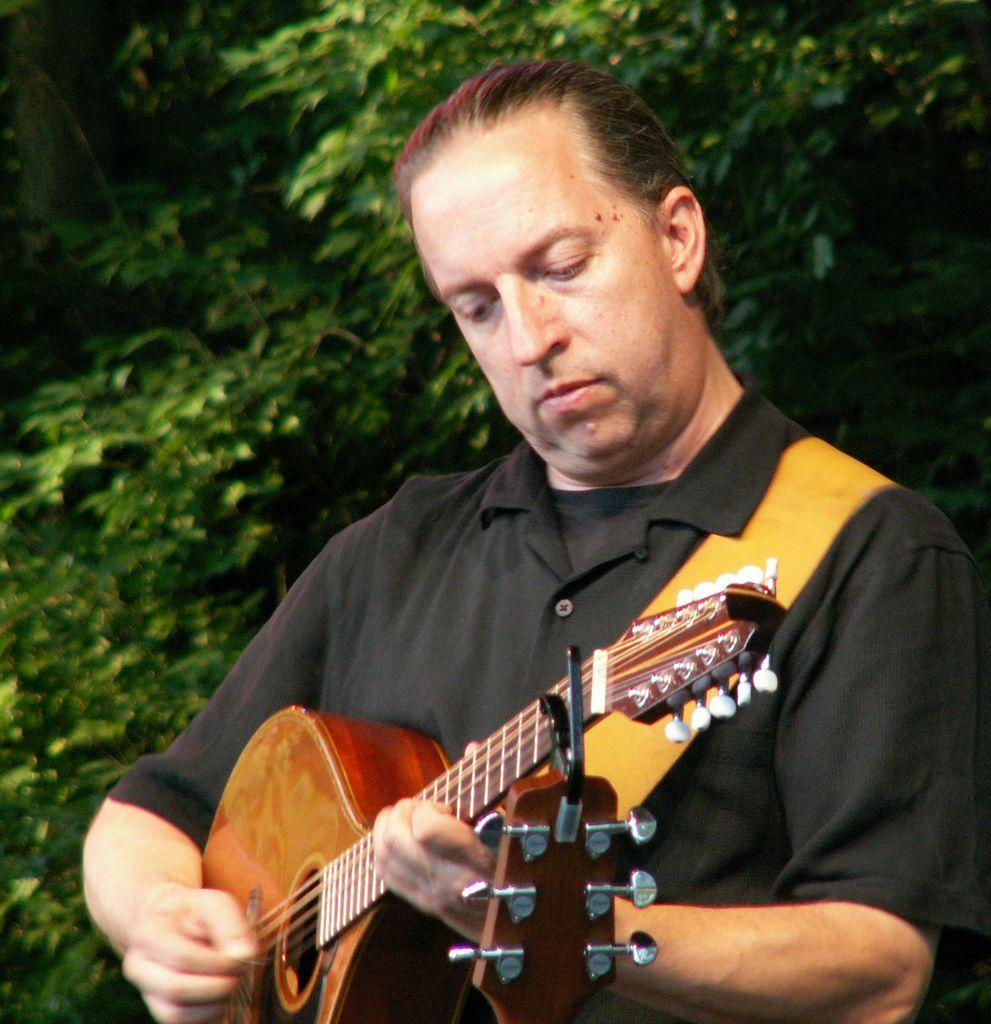What is the person in the image doing? The person is playing a guitar. What can be seen in the background of the image? There are trees in the background of the image. What is the size of the guitar in the image? The size of the guitar cannot be determined from the image alone, as there is no reference for scale. 